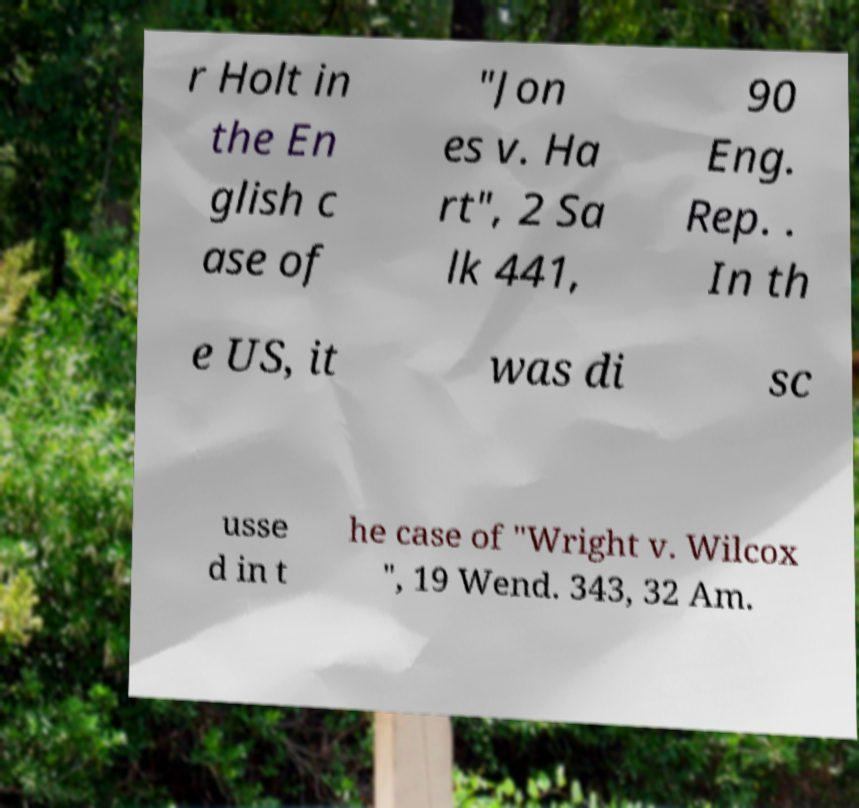Could you assist in decoding the text presented in this image and type it out clearly? r Holt in the En glish c ase of "Jon es v. Ha rt", 2 Sa lk 441, 90 Eng. Rep. . In th e US, it was di sc usse d in t he case of "Wright v. Wilcox ", 19 Wend. 343, 32 Am. 